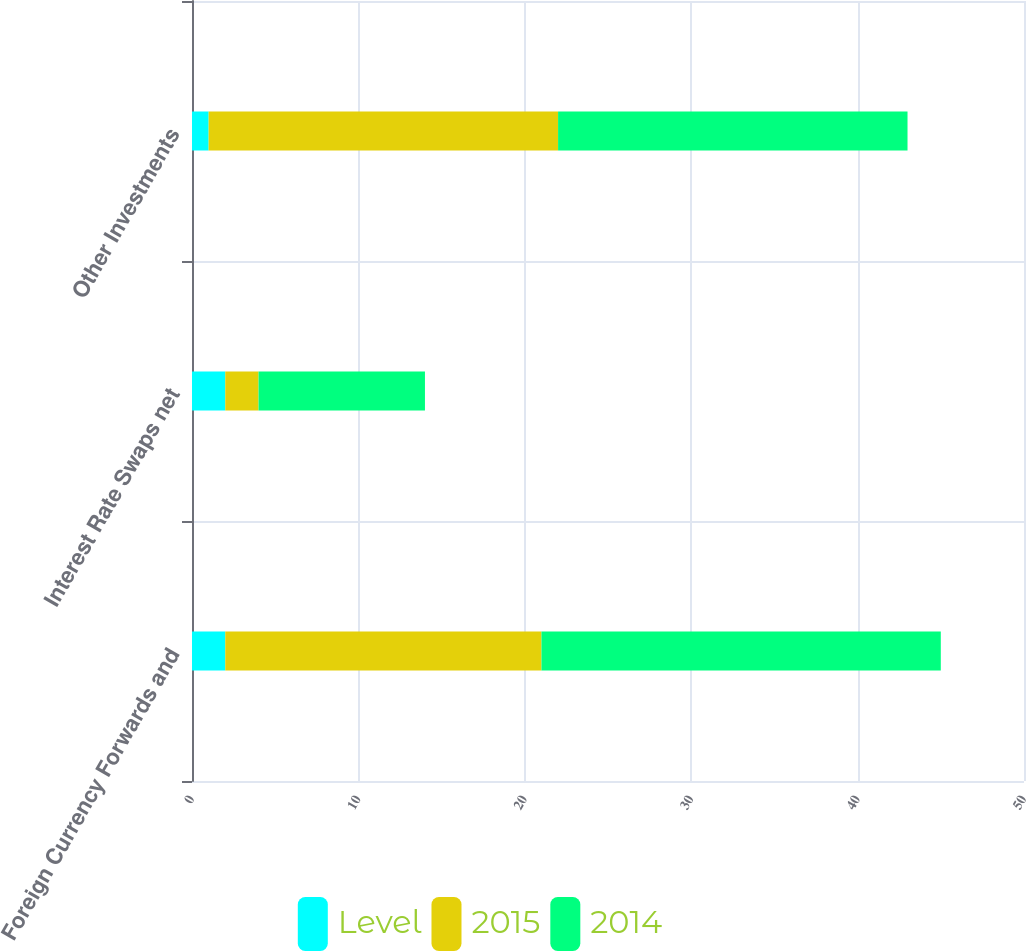Convert chart. <chart><loc_0><loc_0><loc_500><loc_500><stacked_bar_chart><ecel><fcel>Foreign Currency Forwards and<fcel>Interest Rate Swaps net<fcel>Other Investments<nl><fcel>Level<fcel>2<fcel>2<fcel>1<nl><fcel>2015<fcel>19<fcel>2<fcel>21<nl><fcel>2014<fcel>24<fcel>10<fcel>21<nl></chart> 